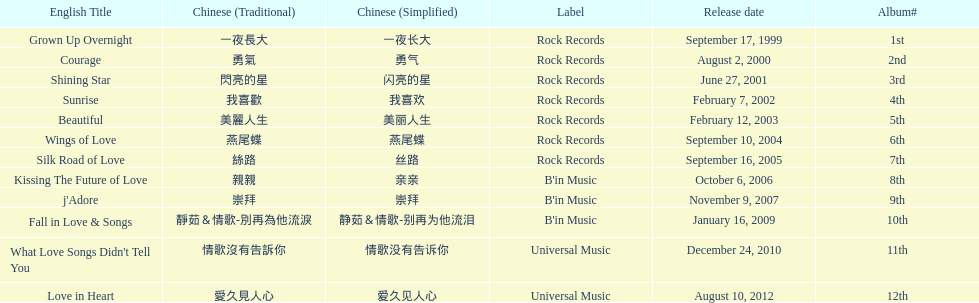Which was the only album to be released by b'in music in an even-numbered year? Kissing The Future of Love. 